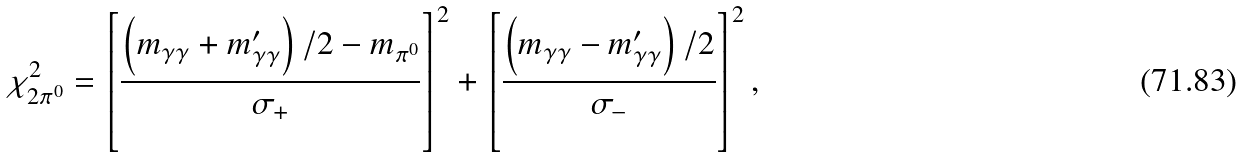Convert formula to latex. <formula><loc_0><loc_0><loc_500><loc_500>\chi _ { 2 \pi ^ { 0 } } ^ { 2 } = \left [ \frac { \left ( m _ { \gamma \gamma } + m ^ { \prime } _ { \gamma \gamma } \right ) / 2 - m _ { \pi ^ { 0 } } } { \sigma _ { + } } \right ] ^ { 2 } + \left [ \frac { \left ( m _ { \gamma \gamma } - m ^ { \prime } _ { \gamma \gamma } \right ) / 2 } { \sigma _ { - } } \right ] ^ { 2 } ,</formula> 